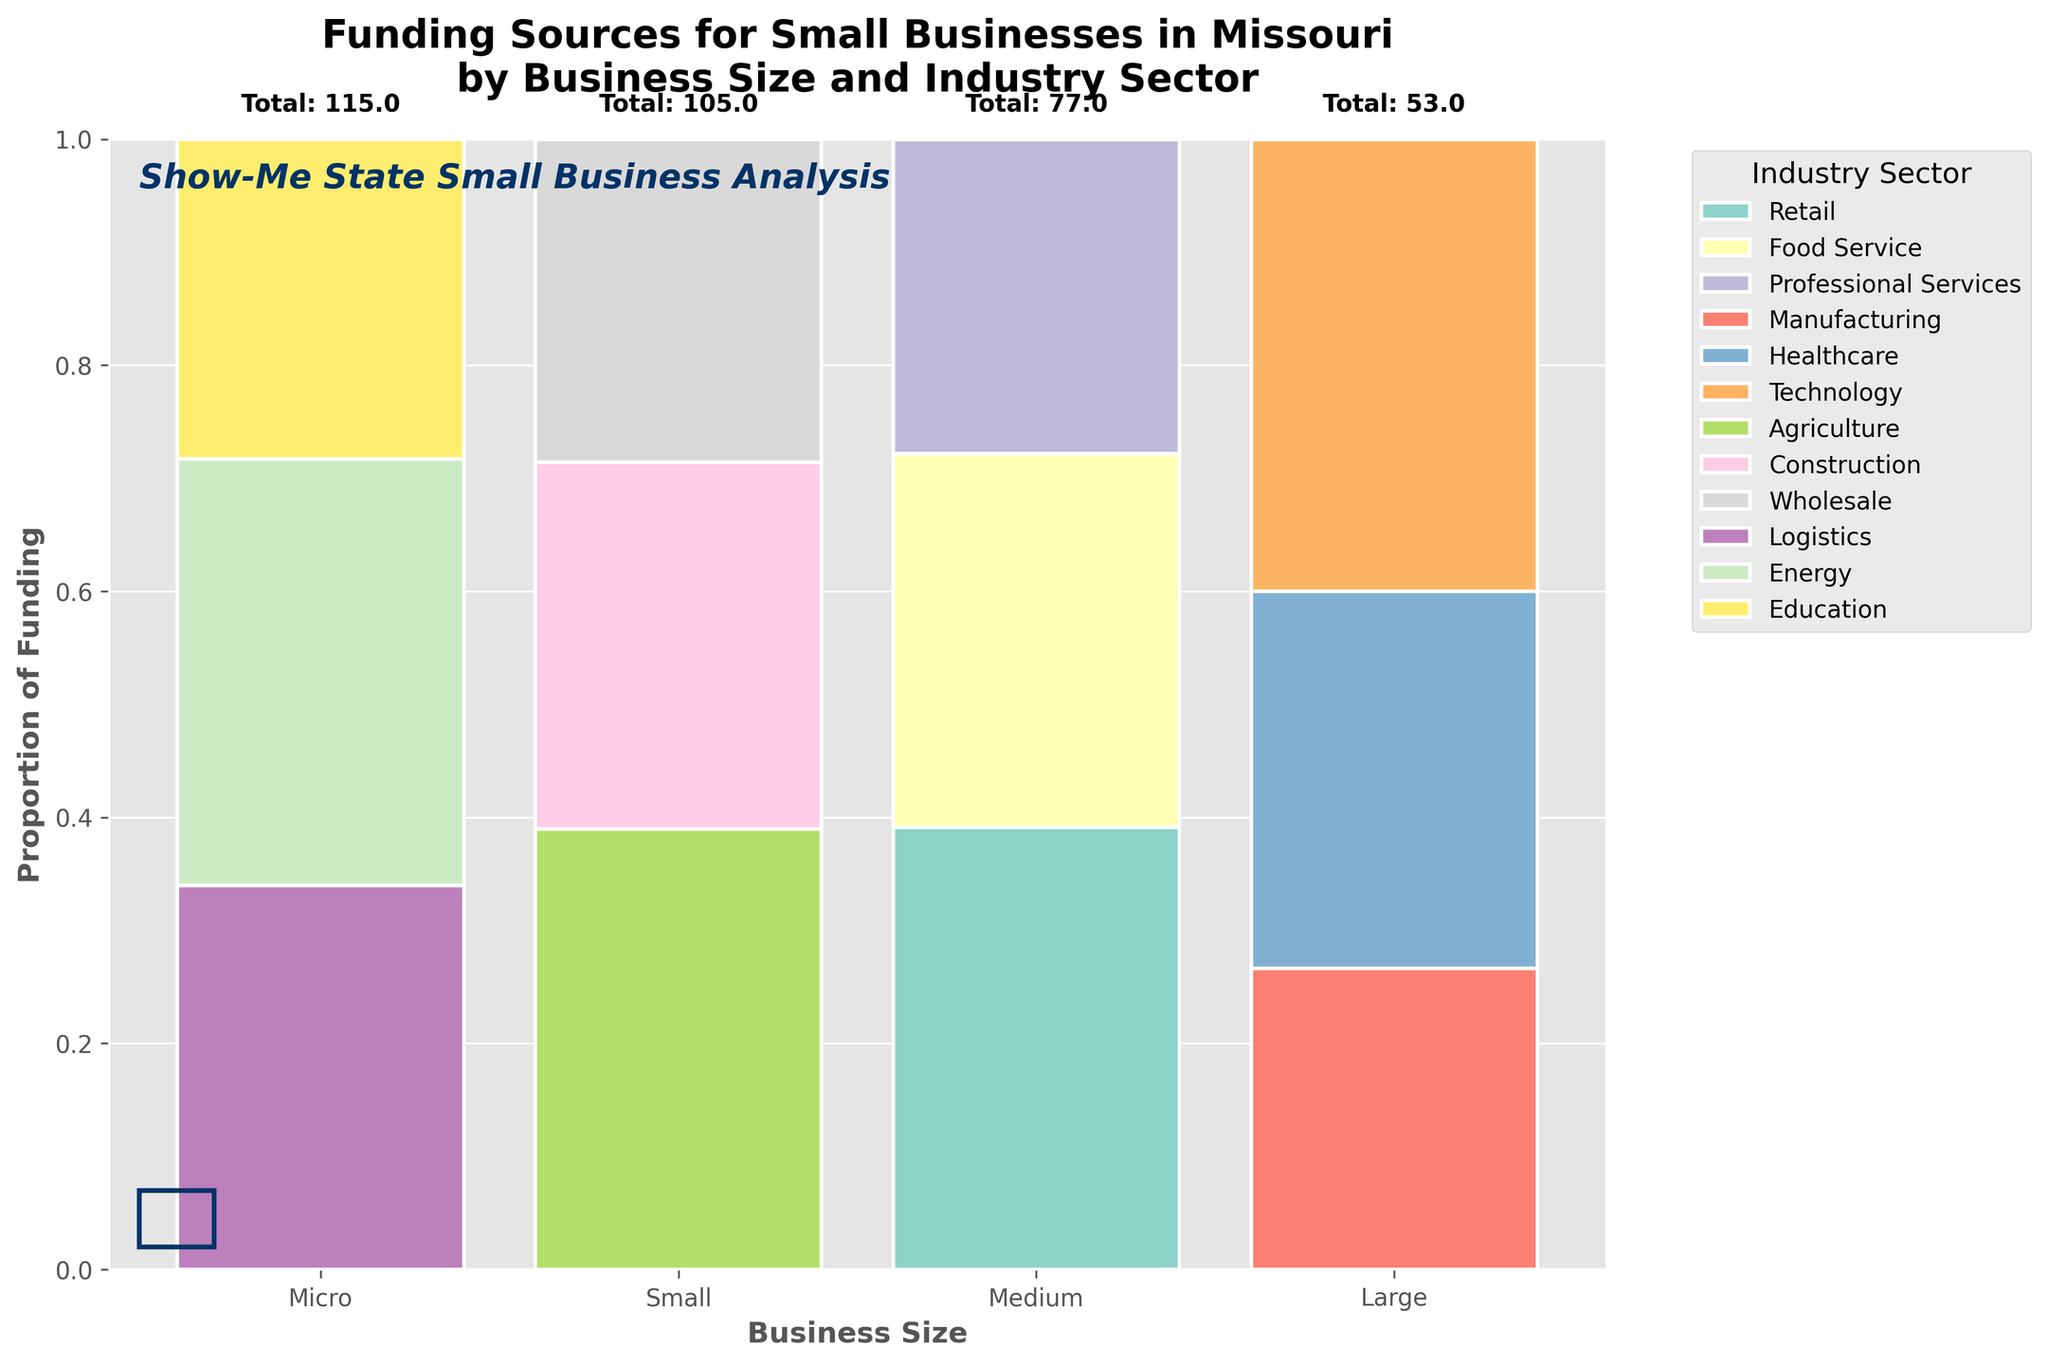What is the title of the plot? The title is located at the top center of the plot. It provides a summary of the chart's content.
Answer: Funding Sources for Small Businesses in Missouri by Business Size and Industry Sector Which business size has the highest total count across all industry sectors? Look at the data labels for each business size at the top of the bars and find the one with the highest total value.
Answer: Micro What industry sector has the largest proportion of funding for micro-sized businesses? Observe the segment heights within the "Micro" business size bar and identify the tallest segment.
Answer: Retail How do the proportions of funding for healthcare compare between small and medium-sized businesses? Compare the height of the healthcare segment in the "Small" and "Medium" business size bars. Note the differences.
Answer: Higher for Small What is the total count of funding sources for medium-sized businesses? Find the data label on top of the "Medium" business size bar for the total count.
Answer: 77 Among large-sized businesses, which industry sector has the least proportion of funding? Look at the segments within the "Large" business size bar and identify the shortest one.
Answer: Education Do agriculture and construction sectors have higher funding proportions in medium or large-sized businesses? Compare the proportions of the agriculture and construction segments between medium-sized and large-sized bars.
Answer: Medium What Missouri-themed elements are included in the plot's design? Identify the elements added to give the plot a Missouri theme at the bottom and around the plot.
Answer: Show-Me State Small Business Analysis text and a Missouri shape Which industry sectors have consistent funding proportions across all business sizes? Visually inspect the heights of segments for any industry sector that remains relatively stable across micro, small, medium, and large bars.
Answer: Agriculture and Wholesale What business size has the most varied proportion of funding sources across different industry sectors? Examine the bars and find the one where segment heights vary the most significantly.
Answer: Medium 